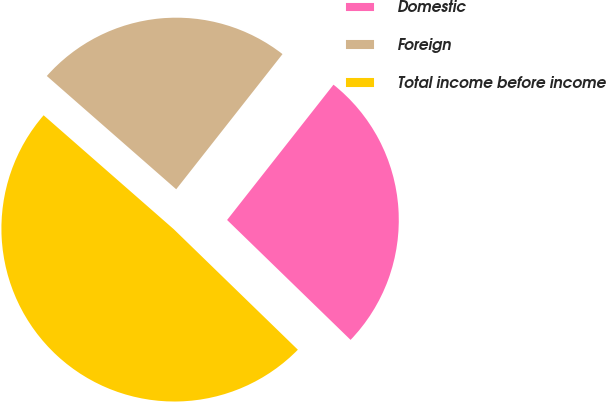Convert chart to OTSL. <chart><loc_0><loc_0><loc_500><loc_500><pie_chart><fcel>Domestic<fcel>Foreign<fcel>Total income before income<nl><fcel>26.66%<fcel>24.16%<fcel>49.18%<nl></chart> 